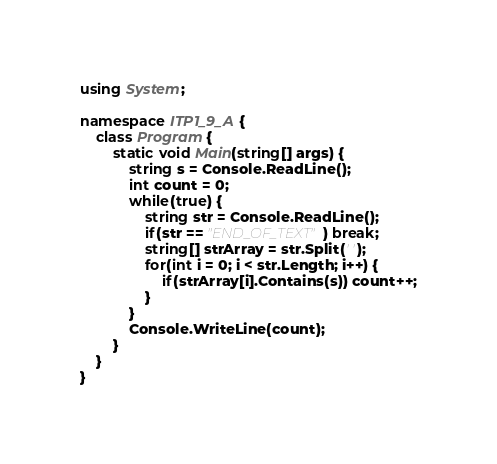Convert code to text. <code><loc_0><loc_0><loc_500><loc_500><_C#_>using System;

namespace ITP1_9_A {
    class Program {
        static void Main(string[] args) {
            string s = Console.ReadLine();
            int count = 0;
            while(true) {
                string str = Console.ReadLine();
                if(str == "END_OF_TEXT") break;
                string[] strArray = str.Split(' ');
                for(int i = 0; i < str.Length; i++) {
                    if(strArray[i].Contains(s)) count++;
                }
            }
            Console.WriteLine(count);
        }
    }
}</code> 